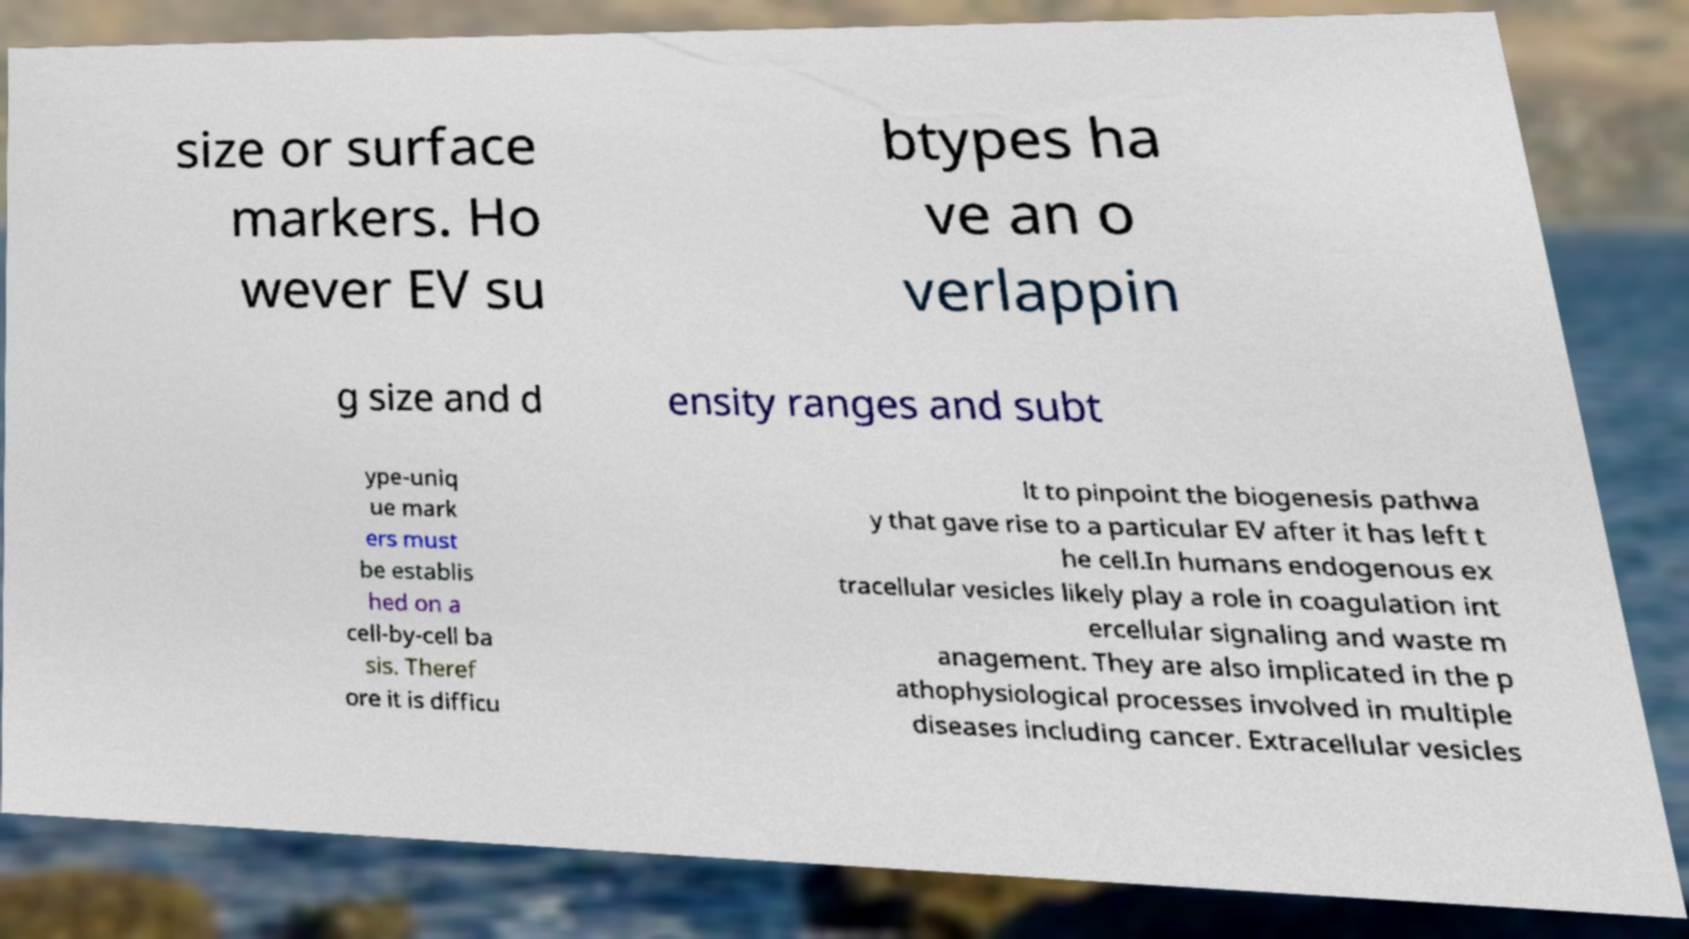Please identify and transcribe the text found in this image. size or surface markers. Ho wever EV su btypes ha ve an o verlappin g size and d ensity ranges and subt ype-uniq ue mark ers must be establis hed on a cell-by-cell ba sis. Theref ore it is difficu lt to pinpoint the biogenesis pathwa y that gave rise to a particular EV after it has left t he cell.In humans endogenous ex tracellular vesicles likely play a role in coagulation int ercellular signaling and waste m anagement. They are also implicated in the p athophysiological processes involved in multiple diseases including cancer. Extracellular vesicles 